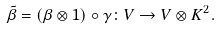Convert formula to latex. <formula><loc_0><loc_0><loc_500><loc_500>\tilde { \beta } = ( \beta \otimes 1 ) \circ \gamma \colon V \to V \otimes K ^ { 2 } .</formula> 